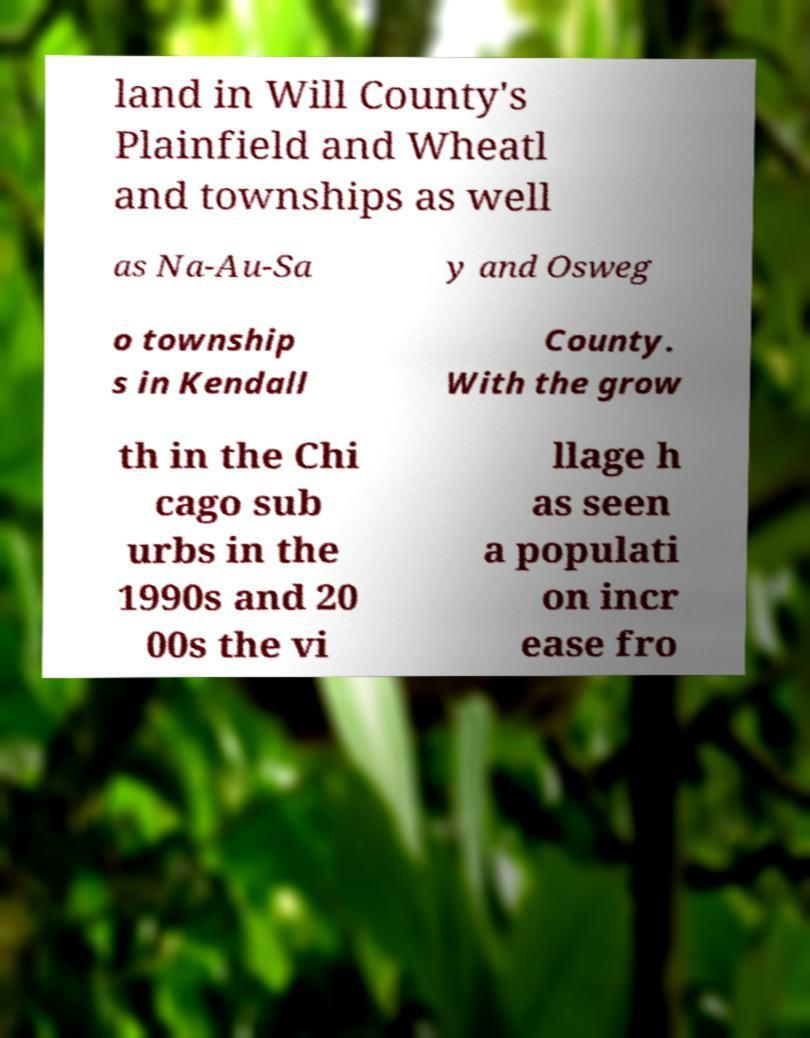Can you accurately transcribe the text from the provided image for me? land in Will County's Plainfield and Wheatl and townships as well as Na-Au-Sa y and Osweg o township s in Kendall County. With the grow th in the Chi cago sub urbs in the 1990s and 20 00s the vi llage h as seen a populati on incr ease fro 